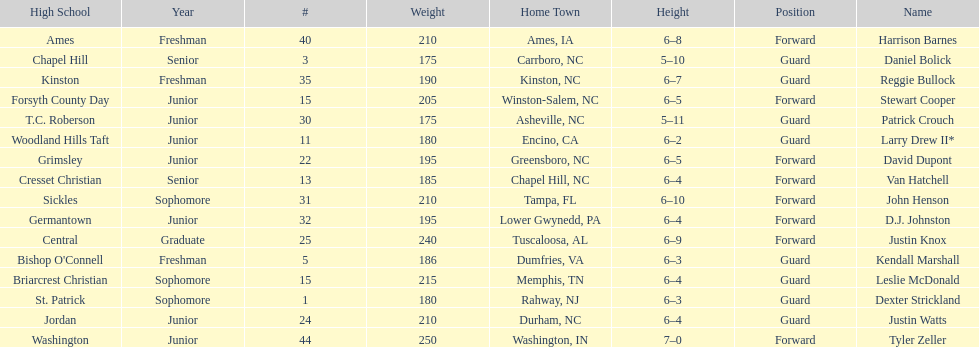How many players were taller than van hatchell? 7. 